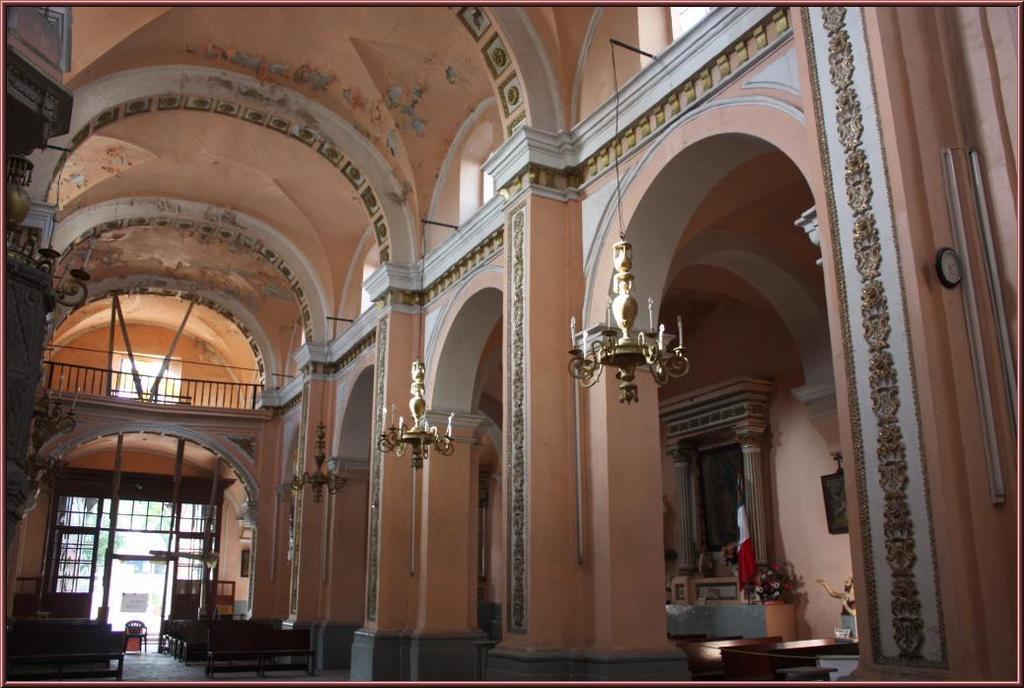In one or two sentences, can you explain what this image depicts? There is a building. It has chandeliers and benches. 